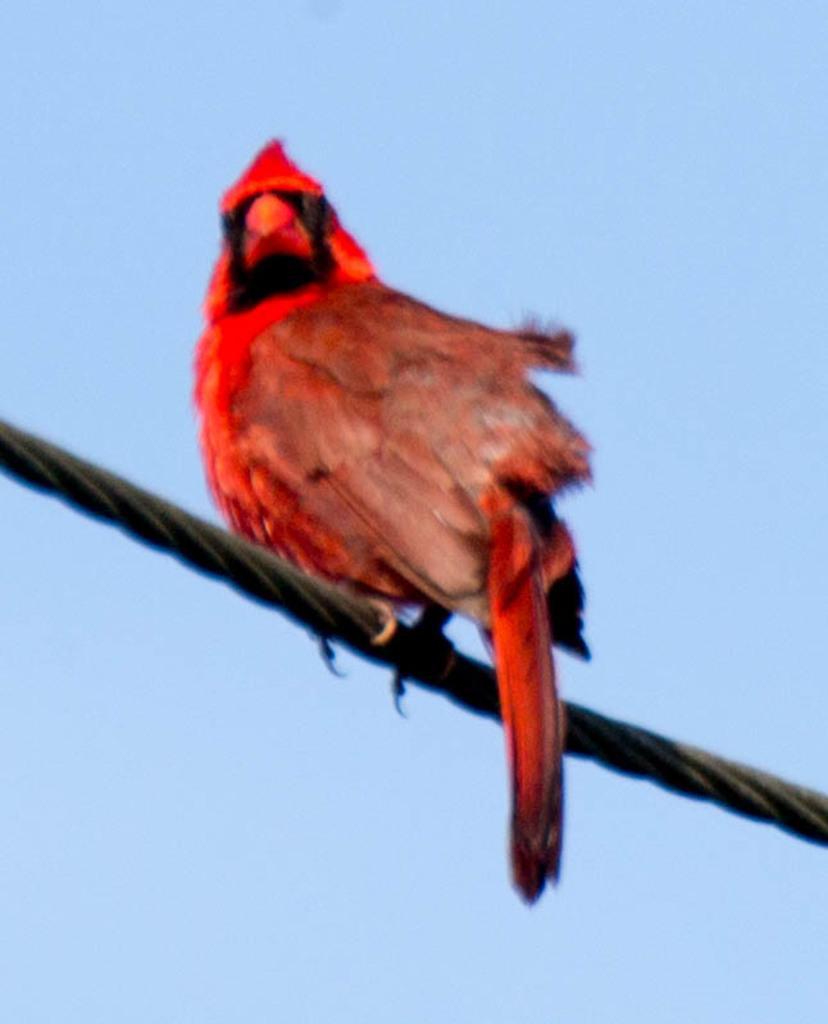Please provide a concise description of this image. In this image there is a bird on the cable. 